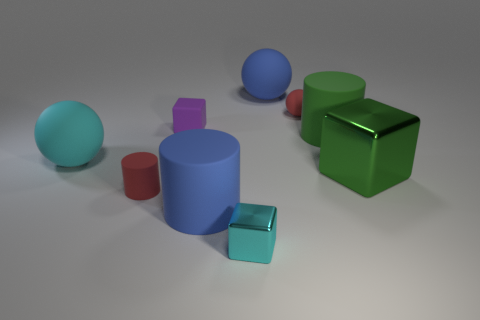Is the shape of the small shiny object the same as the big green metallic object?
Offer a very short reply. Yes. Are there fewer matte cubes that are in front of the cyan sphere than big green cylinders behind the purple cube?
Provide a short and direct response. No. There is a tiny rubber ball; how many red matte cylinders are behind it?
Provide a short and direct response. 0. Is the shape of the small red object that is right of the blue matte cylinder the same as the blue object behind the big green rubber thing?
Offer a terse response. Yes. What number of other objects are there of the same color as the small rubber cylinder?
Offer a terse response. 1. What is the material of the big blue thing behind the large green object in front of the cyan object that is on the left side of the cyan shiny block?
Your response must be concise. Rubber. There is a tiny red thing on the left side of the small matte thing that is to the right of the small cyan cube; what is its material?
Make the answer very short. Rubber. Is the number of red balls behind the small cyan cube less than the number of purple shiny balls?
Provide a short and direct response. No. There is a blue object in front of the big green metallic cube; what shape is it?
Your response must be concise. Cylinder. There is a cyan ball; is its size the same as the matte cylinder that is to the right of the red ball?
Ensure brevity in your answer.  Yes. 